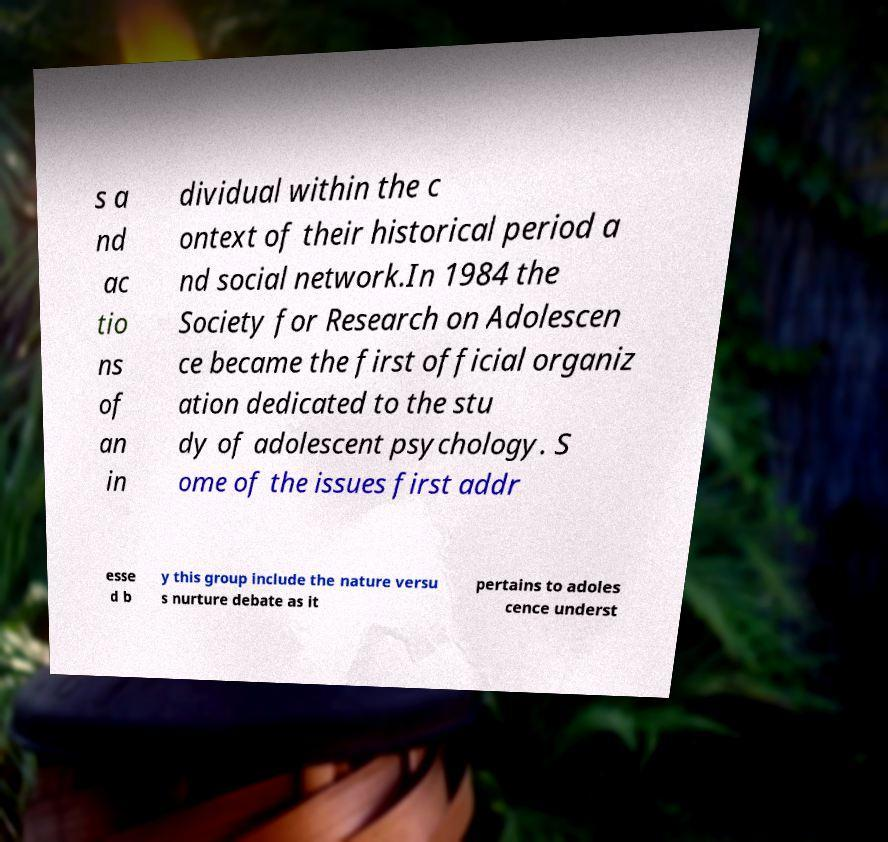Could you assist in decoding the text presented in this image and type it out clearly? s a nd ac tio ns of an in dividual within the c ontext of their historical period a nd social network.In 1984 the Society for Research on Adolescen ce became the first official organiz ation dedicated to the stu dy of adolescent psychology. S ome of the issues first addr esse d b y this group include the nature versu s nurture debate as it pertains to adoles cence underst 